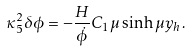Convert formula to latex. <formula><loc_0><loc_0><loc_500><loc_500>\kappa _ { 5 } ^ { 2 } \delta \phi = - \frac { H } { \dot { \phi } } C _ { 1 } \mu \sinh \mu y _ { h } \, .</formula> 